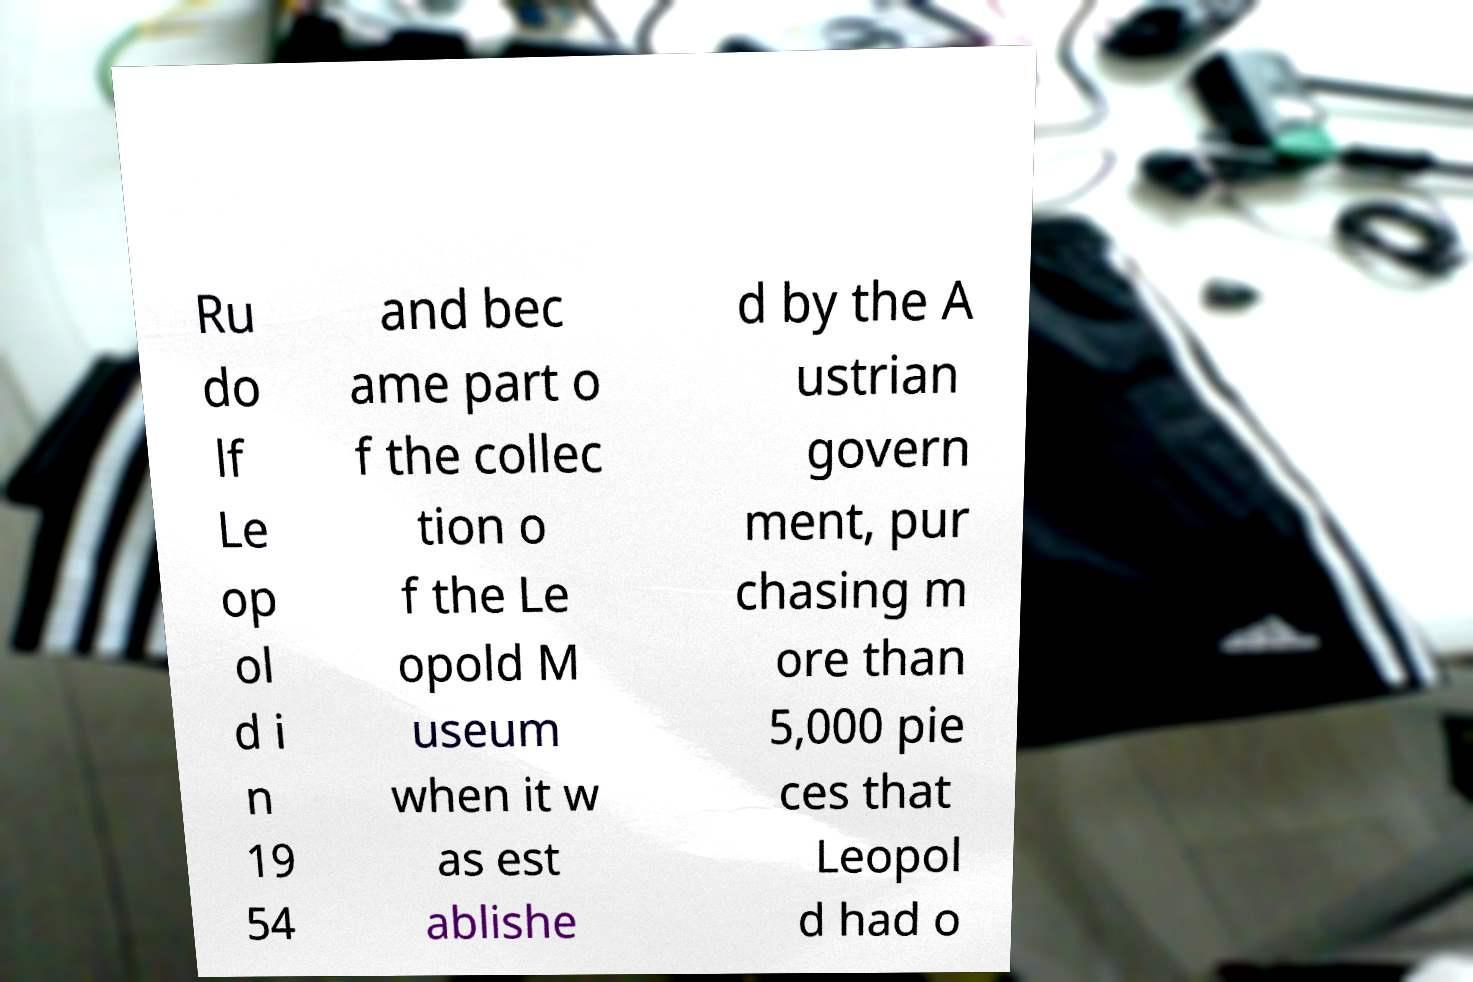Can you accurately transcribe the text from the provided image for me? Ru do lf Le op ol d i n 19 54 and bec ame part o f the collec tion o f the Le opold M useum when it w as est ablishe d by the A ustrian govern ment, pur chasing m ore than 5,000 pie ces that Leopol d had o 